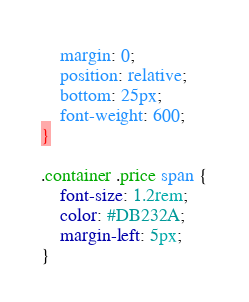Convert code to text. <code><loc_0><loc_0><loc_500><loc_500><_CSS_>    margin: 0;
    position: relative;
    bottom: 25px;
    font-weight: 600;
}

.container .price span {
    font-size: 1.2rem;
    color: #DB232A;
    margin-left: 5px;
}</code> 